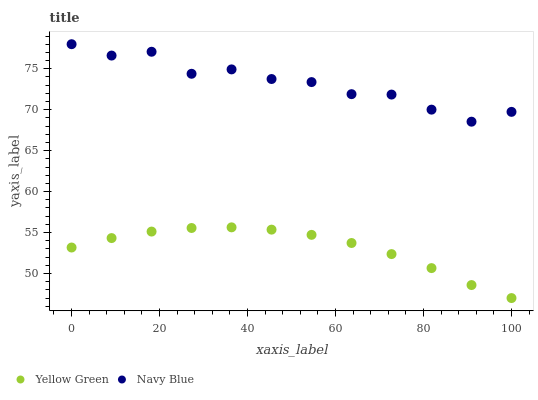Does Yellow Green have the minimum area under the curve?
Answer yes or no. Yes. Does Navy Blue have the maximum area under the curve?
Answer yes or no. Yes. Does Yellow Green have the maximum area under the curve?
Answer yes or no. No. Is Yellow Green the smoothest?
Answer yes or no. Yes. Is Navy Blue the roughest?
Answer yes or no. Yes. Is Yellow Green the roughest?
Answer yes or no. No. Does Yellow Green have the lowest value?
Answer yes or no. Yes. Does Navy Blue have the highest value?
Answer yes or no. Yes. Does Yellow Green have the highest value?
Answer yes or no. No. Is Yellow Green less than Navy Blue?
Answer yes or no. Yes. Is Navy Blue greater than Yellow Green?
Answer yes or no. Yes. Does Yellow Green intersect Navy Blue?
Answer yes or no. No. 